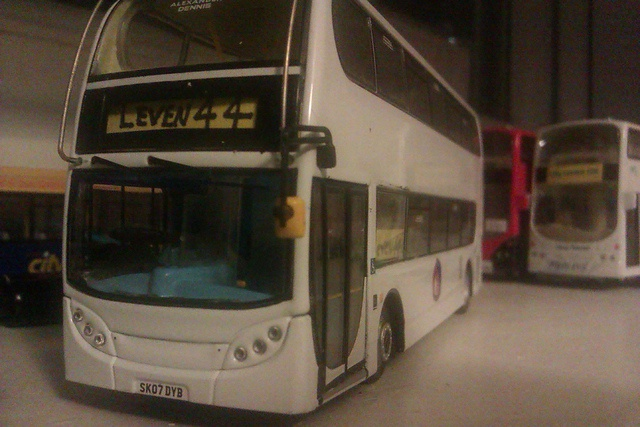Describe the objects in this image and their specific colors. I can see bus in black and gray tones, bus in black, maroon, and gray tones, and bus in black, maroon, and brown tones in this image. 